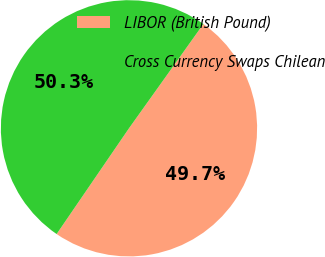Convert chart. <chart><loc_0><loc_0><loc_500><loc_500><pie_chart><fcel>LIBOR (British Pound)<fcel>Cross Currency Swaps Chilean<nl><fcel>49.69%<fcel>50.31%<nl></chart> 